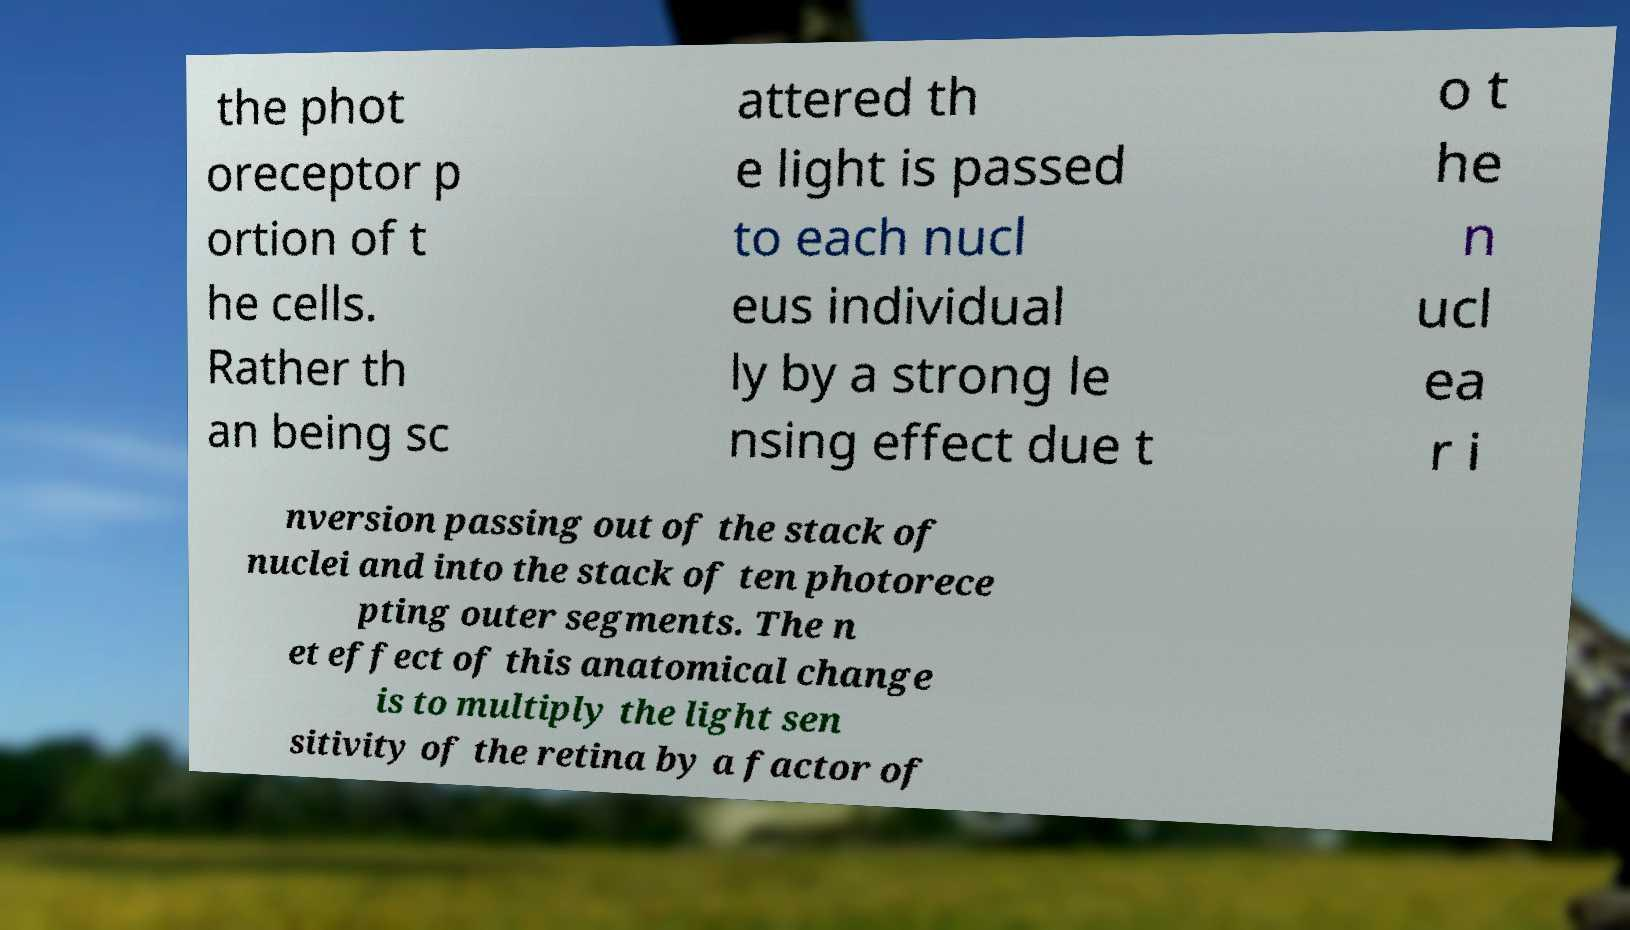Please read and relay the text visible in this image. What does it say? the phot oreceptor p ortion of t he cells. Rather th an being sc attered th e light is passed to each nucl eus individual ly by a strong le nsing effect due t o t he n ucl ea r i nversion passing out of the stack of nuclei and into the stack of ten photorece pting outer segments. The n et effect of this anatomical change is to multiply the light sen sitivity of the retina by a factor of 